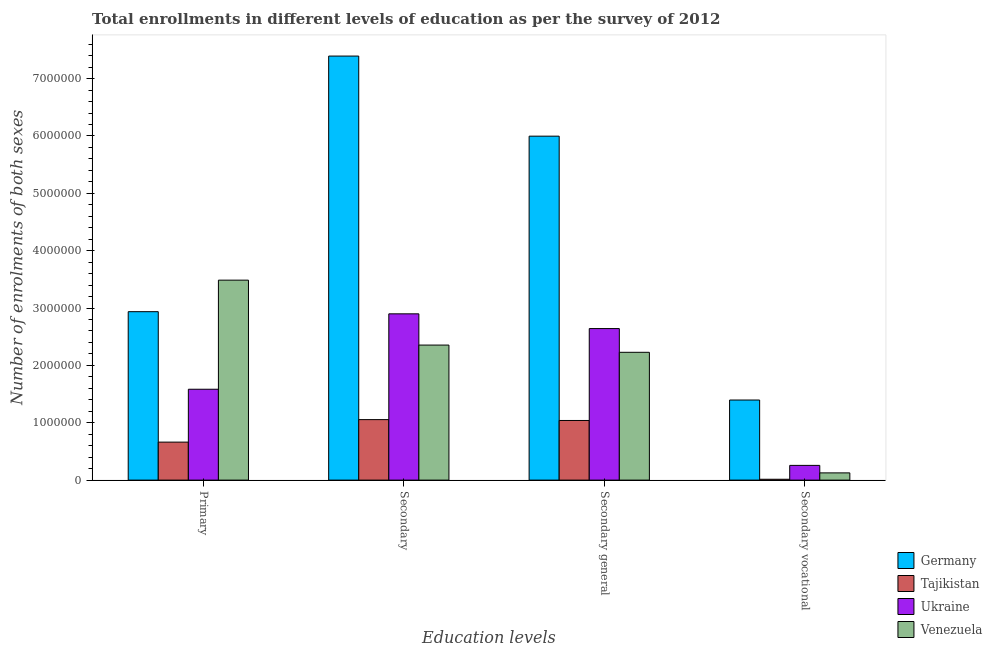How many bars are there on the 4th tick from the left?
Offer a terse response. 4. How many bars are there on the 2nd tick from the right?
Your response must be concise. 4. What is the label of the 4th group of bars from the left?
Give a very brief answer. Secondary vocational. What is the number of enrolments in primary education in Ukraine?
Your answer should be very brief. 1.58e+06. Across all countries, what is the maximum number of enrolments in primary education?
Your answer should be very brief. 3.49e+06. Across all countries, what is the minimum number of enrolments in primary education?
Make the answer very short. 6.63e+05. In which country was the number of enrolments in primary education maximum?
Ensure brevity in your answer.  Venezuela. In which country was the number of enrolments in primary education minimum?
Offer a terse response. Tajikistan. What is the total number of enrolments in secondary vocational education in the graph?
Your answer should be compact. 1.79e+06. What is the difference between the number of enrolments in primary education in Venezuela and that in Tajikistan?
Give a very brief answer. 2.82e+06. What is the difference between the number of enrolments in secondary education in Venezuela and the number of enrolments in secondary general education in Tajikistan?
Make the answer very short. 1.31e+06. What is the average number of enrolments in secondary education per country?
Provide a short and direct response. 3.43e+06. What is the difference between the number of enrolments in secondary education and number of enrolments in primary education in Tajikistan?
Your answer should be very brief. 3.92e+05. What is the ratio of the number of enrolments in secondary education in Ukraine to that in Germany?
Ensure brevity in your answer.  0.39. Is the number of enrolments in primary education in Tajikistan less than that in Germany?
Give a very brief answer. Yes. Is the difference between the number of enrolments in secondary education in Tajikistan and Venezuela greater than the difference between the number of enrolments in secondary vocational education in Tajikistan and Venezuela?
Provide a succinct answer. No. What is the difference between the highest and the second highest number of enrolments in primary education?
Your answer should be very brief. 5.50e+05. What is the difference between the highest and the lowest number of enrolments in primary education?
Your response must be concise. 2.82e+06. In how many countries, is the number of enrolments in primary education greater than the average number of enrolments in primary education taken over all countries?
Offer a very short reply. 2. Is the sum of the number of enrolments in primary education in Ukraine and Germany greater than the maximum number of enrolments in secondary general education across all countries?
Offer a terse response. No. Is it the case that in every country, the sum of the number of enrolments in secondary vocational education and number of enrolments in secondary education is greater than the sum of number of enrolments in primary education and number of enrolments in secondary general education?
Give a very brief answer. Yes. What does the 2nd bar from the left in Secondary general represents?
Keep it short and to the point. Tajikistan. What does the 1st bar from the right in Secondary vocational represents?
Your response must be concise. Venezuela. How many countries are there in the graph?
Your answer should be compact. 4. How are the legend labels stacked?
Your answer should be compact. Vertical. What is the title of the graph?
Make the answer very short. Total enrollments in different levels of education as per the survey of 2012. What is the label or title of the X-axis?
Offer a terse response. Education levels. What is the label or title of the Y-axis?
Offer a very short reply. Number of enrolments of both sexes. What is the Number of enrolments of both sexes in Germany in Primary?
Your answer should be very brief. 2.94e+06. What is the Number of enrolments of both sexes of Tajikistan in Primary?
Your answer should be compact. 6.63e+05. What is the Number of enrolments of both sexes of Ukraine in Primary?
Offer a very short reply. 1.58e+06. What is the Number of enrolments of both sexes in Venezuela in Primary?
Give a very brief answer. 3.49e+06. What is the Number of enrolments of both sexes in Germany in Secondary?
Provide a succinct answer. 7.39e+06. What is the Number of enrolments of both sexes in Tajikistan in Secondary?
Ensure brevity in your answer.  1.05e+06. What is the Number of enrolments of both sexes in Ukraine in Secondary?
Your answer should be compact. 2.90e+06. What is the Number of enrolments of both sexes in Venezuela in Secondary?
Ensure brevity in your answer.  2.35e+06. What is the Number of enrolments of both sexes in Germany in Secondary general?
Offer a terse response. 6.00e+06. What is the Number of enrolments of both sexes in Tajikistan in Secondary general?
Offer a terse response. 1.04e+06. What is the Number of enrolments of both sexes of Ukraine in Secondary general?
Ensure brevity in your answer.  2.64e+06. What is the Number of enrolments of both sexes in Venezuela in Secondary general?
Offer a terse response. 2.23e+06. What is the Number of enrolments of both sexes of Germany in Secondary vocational?
Your answer should be very brief. 1.40e+06. What is the Number of enrolments of both sexes in Tajikistan in Secondary vocational?
Offer a terse response. 1.51e+04. What is the Number of enrolments of both sexes of Ukraine in Secondary vocational?
Your answer should be very brief. 2.57e+05. What is the Number of enrolments of both sexes of Venezuela in Secondary vocational?
Provide a succinct answer. 1.26e+05. Across all Education levels, what is the maximum Number of enrolments of both sexes of Germany?
Make the answer very short. 7.39e+06. Across all Education levels, what is the maximum Number of enrolments of both sexes of Tajikistan?
Give a very brief answer. 1.05e+06. Across all Education levels, what is the maximum Number of enrolments of both sexes of Ukraine?
Make the answer very short. 2.90e+06. Across all Education levels, what is the maximum Number of enrolments of both sexes of Venezuela?
Your response must be concise. 3.49e+06. Across all Education levels, what is the minimum Number of enrolments of both sexes in Germany?
Provide a succinct answer. 1.40e+06. Across all Education levels, what is the minimum Number of enrolments of both sexes in Tajikistan?
Ensure brevity in your answer.  1.51e+04. Across all Education levels, what is the minimum Number of enrolments of both sexes in Ukraine?
Give a very brief answer. 2.57e+05. Across all Education levels, what is the minimum Number of enrolments of both sexes of Venezuela?
Provide a succinct answer. 1.26e+05. What is the total Number of enrolments of both sexes in Germany in the graph?
Your answer should be very brief. 1.77e+07. What is the total Number of enrolments of both sexes in Tajikistan in the graph?
Ensure brevity in your answer.  2.77e+06. What is the total Number of enrolments of both sexes in Ukraine in the graph?
Your response must be concise. 7.38e+06. What is the total Number of enrolments of both sexes of Venezuela in the graph?
Provide a short and direct response. 8.20e+06. What is the difference between the Number of enrolments of both sexes in Germany in Primary and that in Secondary?
Provide a succinct answer. -4.46e+06. What is the difference between the Number of enrolments of both sexes of Tajikistan in Primary and that in Secondary?
Your response must be concise. -3.92e+05. What is the difference between the Number of enrolments of both sexes of Ukraine in Primary and that in Secondary?
Provide a succinct answer. -1.31e+06. What is the difference between the Number of enrolments of both sexes of Venezuela in Primary and that in Secondary?
Offer a terse response. 1.13e+06. What is the difference between the Number of enrolments of both sexes in Germany in Primary and that in Secondary general?
Offer a terse response. -3.06e+06. What is the difference between the Number of enrolments of both sexes in Tajikistan in Primary and that in Secondary general?
Your answer should be compact. -3.77e+05. What is the difference between the Number of enrolments of both sexes in Ukraine in Primary and that in Secondary general?
Keep it short and to the point. -1.06e+06. What is the difference between the Number of enrolments of both sexes of Venezuela in Primary and that in Secondary general?
Provide a succinct answer. 1.26e+06. What is the difference between the Number of enrolments of both sexes in Germany in Primary and that in Secondary vocational?
Ensure brevity in your answer.  1.54e+06. What is the difference between the Number of enrolments of both sexes in Tajikistan in Primary and that in Secondary vocational?
Provide a short and direct response. 6.47e+05. What is the difference between the Number of enrolments of both sexes of Ukraine in Primary and that in Secondary vocational?
Your response must be concise. 1.33e+06. What is the difference between the Number of enrolments of both sexes in Venezuela in Primary and that in Secondary vocational?
Provide a succinct answer. 3.36e+06. What is the difference between the Number of enrolments of both sexes of Germany in Secondary and that in Secondary general?
Offer a very short reply. 1.40e+06. What is the difference between the Number of enrolments of both sexes of Tajikistan in Secondary and that in Secondary general?
Keep it short and to the point. 1.51e+04. What is the difference between the Number of enrolments of both sexes of Ukraine in Secondary and that in Secondary general?
Provide a succinct answer. 2.57e+05. What is the difference between the Number of enrolments of both sexes of Venezuela in Secondary and that in Secondary general?
Make the answer very short. 1.26e+05. What is the difference between the Number of enrolments of both sexes of Germany in Secondary and that in Secondary vocational?
Your answer should be compact. 6.00e+06. What is the difference between the Number of enrolments of both sexes in Tajikistan in Secondary and that in Secondary vocational?
Offer a very short reply. 1.04e+06. What is the difference between the Number of enrolments of both sexes in Ukraine in Secondary and that in Secondary vocational?
Your answer should be very brief. 2.64e+06. What is the difference between the Number of enrolments of both sexes in Venezuela in Secondary and that in Secondary vocational?
Provide a succinct answer. 2.23e+06. What is the difference between the Number of enrolments of both sexes of Germany in Secondary general and that in Secondary vocational?
Ensure brevity in your answer.  4.60e+06. What is the difference between the Number of enrolments of both sexes of Tajikistan in Secondary general and that in Secondary vocational?
Offer a very short reply. 1.02e+06. What is the difference between the Number of enrolments of both sexes of Ukraine in Secondary general and that in Secondary vocational?
Your answer should be very brief. 2.39e+06. What is the difference between the Number of enrolments of both sexes of Venezuela in Secondary general and that in Secondary vocational?
Your answer should be compact. 2.10e+06. What is the difference between the Number of enrolments of both sexes in Germany in Primary and the Number of enrolments of both sexes in Tajikistan in Secondary?
Keep it short and to the point. 1.88e+06. What is the difference between the Number of enrolments of both sexes of Germany in Primary and the Number of enrolments of both sexes of Ukraine in Secondary?
Make the answer very short. 3.76e+04. What is the difference between the Number of enrolments of both sexes of Germany in Primary and the Number of enrolments of both sexes of Venezuela in Secondary?
Give a very brief answer. 5.82e+05. What is the difference between the Number of enrolments of both sexes in Tajikistan in Primary and the Number of enrolments of both sexes in Ukraine in Secondary?
Offer a very short reply. -2.24e+06. What is the difference between the Number of enrolments of both sexes in Tajikistan in Primary and the Number of enrolments of both sexes in Venezuela in Secondary?
Ensure brevity in your answer.  -1.69e+06. What is the difference between the Number of enrolments of both sexes of Ukraine in Primary and the Number of enrolments of both sexes of Venezuela in Secondary?
Your answer should be very brief. -7.70e+05. What is the difference between the Number of enrolments of both sexes of Germany in Primary and the Number of enrolments of both sexes of Tajikistan in Secondary general?
Keep it short and to the point. 1.90e+06. What is the difference between the Number of enrolments of both sexes in Germany in Primary and the Number of enrolments of both sexes in Ukraine in Secondary general?
Your answer should be compact. 2.95e+05. What is the difference between the Number of enrolments of both sexes of Germany in Primary and the Number of enrolments of both sexes of Venezuela in Secondary general?
Your answer should be compact. 7.08e+05. What is the difference between the Number of enrolments of both sexes of Tajikistan in Primary and the Number of enrolments of both sexes of Ukraine in Secondary general?
Provide a succinct answer. -1.98e+06. What is the difference between the Number of enrolments of both sexes in Tajikistan in Primary and the Number of enrolments of both sexes in Venezuela in Secondary general?
Offer a very short reply. -1.57e+06. What is the difference between the Number of enrolments of both sexes in Ukraine in Primary and the Number of enrolments of both sexes in Venezuela in Secondary general?
Keep it short and to the point. -6.44e+05. What is the difference between the Number of enrolments of both sexes of Germany in Primary and the Number of enrolments of both sexes of Tajikistan in Secondary vocational?
Provide a succinct answer. 2.92e+06. What is the difference between the Number of enrolments of both sexes in Germany in Primary and the Number of enrolments of both sexes in Ukraine in Secondary vocational?
Your response must be concise. 2.68e+06. What is the difference between the Number of enrolments of both sexes of Germany in Primary and the Number of enrolments of both sexes of Venezuela in Secondary vocational?
Your answer should be very brief. 2.81e+06. What is the difference between the Number of enrolments of both sexes of Tajikistan in Primary and the Number of enrolments of both sexes of Ukraine in Secondary vocational?
Provide a short and direct response. 4.06e+05. What is the difference between the Number of enrolments of both sexes in Tajikistan in Primary and the Number of enrolments of both sexes in Venezuela in Secondary vocational?
Offer a very short reply. 5.36e+05. What is the difference between the Number of enrolments of both sexes of Ukraine in Primary and the Number of enrolments of both sexes of Venezuela in Secondary vocational?
Give a very brief answer. 1.46e+06. What is the difference between the Number of enrolments of both sexes of Germany in Secondary and the Number of enrolments of both sexes of Tajikistan in Secondary general?
Provide a short and direct response. 6.35e+06. What is the difference between the Number of enrolments of both sexes of Germany in Secondary and the Number of enrolments of both sexes of Ukraine in Secondary general?
Make the answer very short. 4.75e+06. What is the difference between the Number of enrolments of both sexes in Germany in Secondary and the Number of enrolments of both sexes in Venezuela in Secondary general?
Provide a succinct answer. 5.16e+06. What is the difference between the Number of enrolments of both sexes of Tajikistan in Secondary and the Number of enrolments of both sexes of Ukraine in Secondary general?
Give a very brief answer. -1.59e+06. What is the difference between the Number of enrolments of both sexes of Tajikistan in Secondary and the Number of enrolments of both sexes of Venezuela in Secondary general?
Offer a terse response. -1.17e+06. What is the difference between the Number of enrolments of both sexes in Ukraine in Secondary and the Number of enrolments of both sexes in Venezuela in Secondary general?
Provide a short and direct response. 6.71e+05. What is the difference between the Number of enrolments of both sexes in Germany in Secondary and the Number of enrolments of both sexes in Tajikistan in Secondary vocational?
Provide a short and direct response. 7.38e+06. What is the difference between the Number of enrolments of both sexes of Germany in Secondary and the Number of enrolments of both sexes of Ukraine in Secondary vocational?
Offer a terse response. 7.14e+06. What is the difference between the Number of enrolments of both sexes of Germany in Secondary and the Number of enrolments of both sexes of Venezuela in Secondary vocational?
Provide a short and direct response. 7.27e+06. What is the difference between the Number of enrolments of both sexes in Tajikistan in Secondary and the Number of enrolments of both sexes in Ukraine in Secondary vocational?
Ensure brevity in your answer.  7.98e+05. What is the difference between the Number of enrolments of both sexes in Tajikistan in Secondary and the Number of enrolments of both sexes in Venezuela in Secondary vocational?
Your answer should be compact. 9.29e+05. What is the difference between the Number of enrolments of both sexes of Ukraine in Secondary and the Number of enrolments of both sexes of Venezuela in Secondary vocational?
Give a very brief answer. 2.77e+06. What is the difference between the Number of enrolments of both sexes of Germany in Secondary general and the Number of enrolments of both sexes of Tajikistan in Secondary vocational?
Your answer should be very brief. 5.98e+06. What is the difference between the Number of enrolments of both sexes in Germany in Secondary general and the Number of enrolments of both sexes in Ukraine in Secondary vocational?
Your answer should be very brief. 5.74e+06. What is the difference between the Number of enrolments of both sexes of Germany in Secondary general and the Number of enrolments of both sexes of Venezuela in Secondary vocational?
Your answer should be compact. 5.87e+06. What is the difference between the Number of enrolments of both sexes in Tajikistan in Secondary general and the Number of enrolments of both sexes in Ukraine in Secondary vocational?
Offer a terse response. 7.83e+05. What is the difference between the Number of enrolments of both sexes in Tajikistan in Secondary general and the Number of enrolments of both sexes in Venezuela in Secondary vocational?
Offer a terse response. 9.14e+05. What is the difference between the Number of enrolments of both sexes of Ukraine in Secondary general and the Number of enrolments of both sexes of Venezuela in Secondary vocational?
Keep it short and to the point. 2.52e+06. What is the average Number of enrolments of both sexes of Germany per Education levels?
Make the answer very short. 4.43e+06. What is the average Number of enrolments of both sexes of Tajikistan per Education levels?
Give a very brief answer. 6.93e+05. What is the average Number of enrolments of both sexes of Ukraine per Education levels?
Provide a short and direct response. 1.85e+06. What is the average Number of enrolments of both sexes in Venezuela per Education levels?
Offer a very short reply. 2.05e+06. What is the difference between the Number of enrolments of both sexes of Germany and Number of enrolments of both sexes of Tajikistan in Primary?
Ensure brevity in your answer.  2.27e+06. What is the difference between the Number of enrolments of both sexes of Germany and Number of enrolments of both sexes of Ukraine in Primary?
Your answer should be compact. 1.35e+06. What is the difference between the Number of enrolments of both sexes of Germany and Number of enrolments of both sexes of Venezuela in Primary?
Make the answer very short. -5.50e+05. What is the difference between the Number of enrolments of both sexes in Tajikistan and Number of enrolments of both sexes in Ukraine in Primary?
Give a very brief answer. -9.22e+05. What is the difference between the Number of enrolments of both sexes in Tajikistan and Number of enrolments of both sexes in Venezuela in Primary?
Ensure brevity in your answer.  -2.82e+06. What is the difference between the Number of enrolments of both sexes of Ukraine and Number of enrolments of both sexes of Venezuela in Primary?
Offer a terse response. -1.90e+06. What is the difference between the Number of enrolments of both sexes in Germany and Number of enrolments of both sexes in Tajikistan in Secondary?
Offer a very short reply. 6.34e+06. What is the difference between the Number of enrolments of both sexes in Germany and Number of enrolments of both sexes in Ukraine in Secondary?
Give a very brief answer. 4.49e+06. What is the difference between the Number of enrolments of both sexes of Germany and Number of enrolments of both sexes of Venezuela in Secondary?
Provide a succinct answer. 5.04e+06. What is the difference between the Number of enrolments of both sexes in Tajikistan and Number of enrolments of both sexes in Ukraine in Secondary?
Your answer should be very brief. -1.84e+06. What is the difference between the Number of enrolments of both sexes in Tajikistan and Number of enrolments of both sexes in Venezuela in Secondary?
Provide a short and direct response. -1.30e+06. What is the difference between the Number of enrolments of both sexes in Ukraine and Number of enrolments of both sexes in Venezuela in Secondary?
Give a very brief answer. 5.45e+05. What is the difference between the Number of enrolments of both sexes of Germany and Number of enrolments of both sexes of Tajikistan in Secondary general?
Your answer should be very brief. 4.96e+06. What is the difference between the Number of enrolments of both sexes of Germany and Number of enrolments of both sexes of Ukraine in Secondary general?
Offer a terse response. 3.35e+06. What is the difference between the Number of enrolments of both sexes of Germany and Number of enrolments of both sexes of Venezuela in Secondary general?
Offer a very short reply. 3.77e+06. What is the difference between the Number of enrolments of both sexes of Tajikistan and Number of enrolments of both sexes of Ukraine in Secondary general?
Provide a short and direct response. -1.60e+06. What is the difference between the Number of enrolments of both sexes of Tajikistan and Number of enrolments of both sexes of Venezuela in Secondary general?
Keep it short and to the point. -1.19e+06. What is the difference between the Number of enrolments of both sexes in Ukraine and Number of enrolments of both sexes in Venezuela in Secondary general?
Your answer should be very brief. 4.14e+05. What is the difference between the Number of enrolments of both sexes in Germany and Number of enrolments of both sexes in Tajikistan in Secondary vocational?
Your answer should be compact. 1.38e+06. What is the difference between the Number of enrolments of both sexes in Germany and Number of enrolments of both sexes in Ukraine in Secondary vocational?
Make the answer very short. 1.14e+06. What is the difference between the Number of enrolments of both sexes of Germany and Number of enrolments of both sexes of Venezuela in Secondary vocational?
Your answer should be very brief. 1.27e+06. What is the difference between the Number of enrolments of both sexes in Tajikistan and Number of enrolments of both sexes in Ukraine in Secondary vocational?
Your response must be concise. -2.42e+05. What is the difference between the Number of enrolments of both sexes of Tajikistan and Number of enrolments of both sexes of Venezuela in Secondary vocational?
Provide a short and direct response. -1.11e+05. What is the difference between the Number of enrolments of both sexes in Ukraine and Number of enrolments of both sexes in Venezuela in Secondary vocational?
Your answer should be compact. 1.31e+05. What is the ratio of the Number of enrolments of both sexes of Germany in Primary to that in Secondary?
Your answer should be very brief. 0.4. What is the ratio of the Number of enrolments of both sexes of Tajikistan in Primary to that in Secondary?
Keep it short and to the point. 0.63. What is the ratio of the Number of enrolments of both sexes of Ukraine in Primary to that in Secondary?
Keep it short and to the point. 0.55. What is the ratio of the Number of enrolments of both sexes of Venezuela in Primary to that in Secondary?
Your answer should be very brief. 1.48. What is the ratio of the Number of enrolments of both sexes of Germany in Primary to that in Secondary general?
Give a very brief answer. 0.49. What is the ratio of the Number of enrolments of both sexes of Tajikistan in Primary to that in Secondary general?
Your response must be concise. 0.64. What is the ratio of the Number of enrolments of both sexes in Ukraine in Primary to that in Secondary general?
Your answer should be very brief. 0.6. What is the ratio of the Number of enrolments of both sexes in Venezuela in Primary to that in Secondary general?
Your answer should be very brief. 1.56. What is the ratio of the Number of enrolments of both sexes of Germany in Primary to that in Secondary vocational?
Offer a very short reply. 2.1. What is the ratio of the Number of enrolments of both sexes in Tajikistan in Primary to that in Secondary vocational?
Offer a terse response. 43.96. What is the ratio of the Number of enrolments of both sexes in Ukraine in Primary to that in Secondary vocational?
Your answer should be compact. 6.17. What is the ratio of the Number of enrolments of both sexes of Venezuela in Primary to that in Secondary vocational?
Your answer should be compact. 27.67. What is the ratio of the Number of enrolments of both sexes in Germany in Secondary to that in Secondary general?
Your answer should be very brief. 1.23. What is the ratio of the Number of enrolments of both sexes in Tajikistan in Secondary to that in Secondary general?
Provide a short and direct response. 1.01. What is the ratio of the Number of enrolments of both sexes in Ukraine in Secondary to that in Secondary general?
Provide a succinct answer. 1.1. What is the ratio of the Number of enrolments of both sexes of Venezuela in Secondary to that in Secondary general?
Your answer should be very brief. 1.06. What is the ratio of the Number of enrolments of both sexes in Germany in Secondary to that in Secondary vocational?
Make the answer very short. 5.29. What is the ratio of the Number of enrolments of both sexes in Tajikistan in Secondary to that in Secondary vocational?
Provide a short and direct response. 69.98. What is the ratio of the Number of enrolments of both sexes of Ukraine in Secondary to that in Secondary vocational?
Keep it short and to the point. 11.28. What is the ratio of the Number of enrolments of both sexes of Venezuela in Secondary to that in Secondary vocational?
Give a very brief answer. 18.68. What is the ratio of the Number of enrolments of both sexes in Germany in Secondary general to that in Secondary vocational?
Keep it short and to the point. 4.29. What is the ratio of the Number of enrolments of both sexes in Tajikistan in Secondary general to that in Secondary vocational?
Make the answer very short. 68.98. What is the ratio of the Number of enrolments of both sexes of Ukraine in Secondary general to that in Secondary vocational?
Your answer should be compact. 10.28. What is the ratio of the Number of enrolments of both sexes of Venezuela in Secondary general to that in Secondary vocational?
Keep it short and to the point. 17.68. What is the difference between the highest and the second highest Number of enrolments of both sexes in Germany?
Keep it short and to the point. 1.40e+06. What is the difference between the highest and the second highest Number of enrolments of both sexes of Tajikistan?
Keep it short and to the point. 1.51e+04. What is the difference between the highest and the second highest Number of enrolments of both sexes in Ukraine?
Your response must be concise. 2.57e+05. What is the difference between the highest and the second highest Number of enrolments of both sexes of Venezuela?
Make the answer very short. 1.13e+06. What is the difference between the highest and the lowest Number of enrolments of both sexes of Germany?
Provide a short and direct response. 6.00e+06. What is the difference between the highest and the lowest Number of enrolments of both sexes of Tajikistan?
Your response must be concise. 1.04e+06. What is the difference between the highest and the lowest Number of enrolments of both sexes in Ukraine?
Offer a very short reply. 2.64e+06. What is the difference between the highest and the lowest Number of enrolments of both sexes in Venezuela?
Make the answer very short. 3.36e+06. 